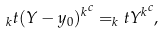Convert formula to latex. <formula><loc_0><loc_0><loc_500><loc_500>_ { k } t { ( Y - y _ { 0 } ) ^ { k } } ^ { c } = _ { k } t { Y ^ { k } } ^ { c } ,</formula> 